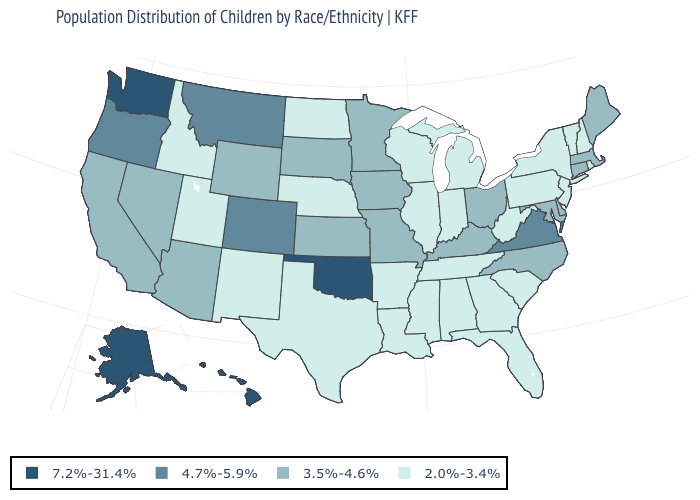What is the lowest value in the USA?
Short answer required. 2.0%-3.4%. How many symbols are there in the legend?
Concise answer only. 4. Which states have the lowest value in the USA?
Concise answer only. Alabama, Arkansas, Florida, Georgia, Idaho, Illinois, Indiana, Louisiana, Michigan, Mississippi, Nebraska, New Hampshire, New Jersey, New Mexico, New York, North Dakota, Pennsylvania, Rhode Island, South Carolina, Tennessee, Texas, Utah, Vermont, West Virginia, Wisconsin. Is the legend a continuous bar?
Keep it brief. No. Among the states that border Wisconsin , which have the lowest value?
Concise answer only. Illinois, Michigan. Among the states that border Illinois , does Kentucky have the highest value?
Answer briefly. Yes. Name the states that have a value in the range 4.7%-5.9%?
Concise answer only. Colorado, Montana, Oregon, Virginia. Does California have the highest value in the USA?
Keep it brief. No. What is the value of Oregon?
Concise answer only. 4.7%-5.9%. Name the states that have a value in the range 4.7%-5.9%?
Be succinct. Colorado, Montana, Oregon, Virginia. Name the states that have a value in the range 4.7%-5.9%?
Quick response, please. Colorado, Montana, Oregon, Virginia. Among the states that border Indiana , which have the lowest value?
Write a very short answer. Illinois, Michigan. Does the first symbol in the legend represent the smallest category?
Write a very short answer. No. Among the states that border South Dakota , does Montana have the highest value?
Short answer required. Yes. Name the states that have a value in the range 2.0%-3.4%?
Be succinct. Alabama, Arkansas, Florida, Georgia, Idaho, Illinois, Indiana, Louisiana, Michigan, Mississippi, Nebraska, New Hampshire, New Jersey, New Mexico, New York, North Dakota, Pennsylvania, Rhode Island, South Carolina, Tennessee, Texas, Utah, Vermont, West Virginia, Wisconsin. 